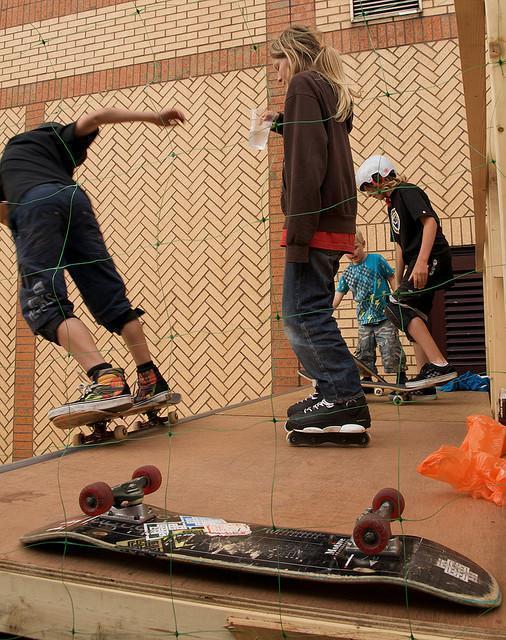This girl has similar hair color to what actress?
Answer the question by selecting the correct answer among the 4 following choices.
Options: Isabelle adjani, brooke shields, jessica chastain, michelle pfeiffer. Michelle pfeiffer. 